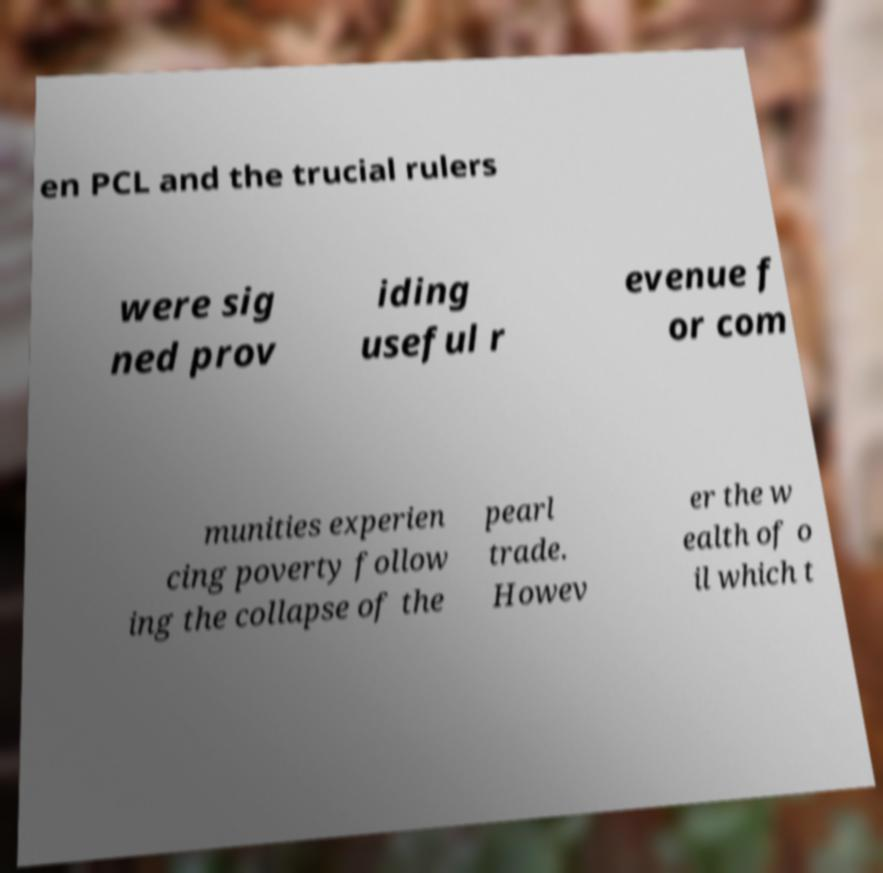Could you extract and type out the text from this image? en PCL and the trucial rulers were sig ned prov iding useful r evenue f or com munities experien cing poverty follow ing the collapse of the pearl trade. Howev er the w ealth of o il which t 